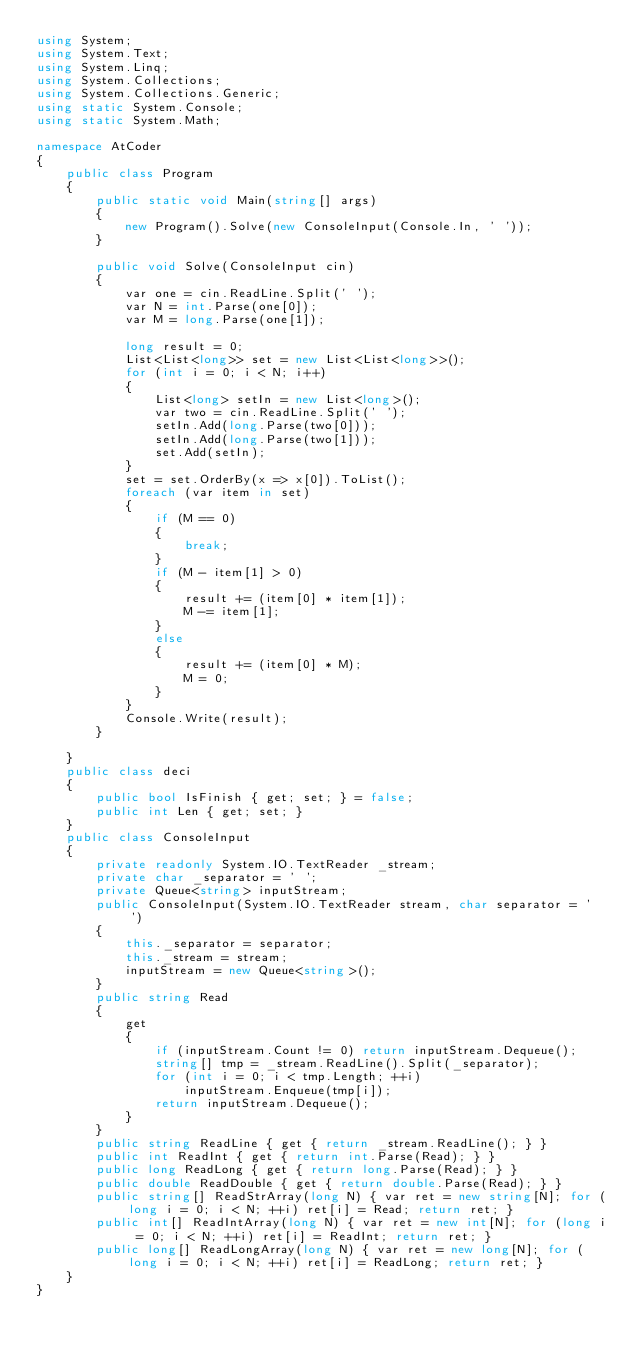<code> <loc_0><loc_0><loc_500><loc_500><_C#_>using System;
using System.Text;
using System.Linq;
using System.Collections;
using System.Collections.Generic;
using static System.Console;
using static System.Math;

namespace AtCoder
{
    public class Program
    {
        public static void Main(string[] args)
        {
            new Program().Solve(new ConsoleInput(Console.In, ' '));
        }

        public void Solve(ConsoleInput cin)
        {
            var one = cin.ReadLine.Split(' ');
            var N = int.Parse(one[0]);
            var M = long.Parse(one[1]);

            long result = 0;
            List<List<long>> set = new List<List<long>>();
            for (int i = 0; i < N; i++)
            {
                List<long> setIn = new List<long>();
                var two = cin.ReadLine.Split(' ');
                setIn.Add(long.Parse(two[0]));
                setIn.Add(long.Parse(two[1]));
                set.Add(setIn);
            }
            set = set.OrderBy(x => x[0]).ToList();
            foreach (var item in set)
            {
                if (M == 0)
                {
                    break;
                }
                if (M - item[1] > 0)
                {
                    result += (item[0] * item[1]);
                    M -= item[1];
                }
                else
                {
                    result += (item[0] * M);
                    M = 0;
                }
            }
            Console.Write(result);
        }

    }
    public class deci
    {
        public bool IsFinish { get; set; } = false;
        public int Len { get; set; }
    }
    public class ConsoleInput
    {
        private readonly System.IO.TextReader _stream;
        private char _separator = ' ';
        private Queue<string> inputStream;
        public ConsoleInput(System.IO.TextReader stream, char separator = ' ')
        {
            this._separator = separator;
            this._stream = stream;
            inputStream = new Queue<string>();
        }
        public string Read
        {
            get
            {
                if (inputStream.Count != 0) return inputStream.Dequeue();
                string[] tmp = _stream.ReadLine().Split(_separator);
                for (int i = 0; i < tmp.Length; ++i)
                    inputStream.Enqueue(tmp[i]);
                return inputStream.Dequeue();
            }
        }
        public string ReadLine { get { return _stream.ReadLine(); } }
        public int ReadInt { get { return int.Parse(Read); } }
        public long ReadLong { get { return long.Parse(Read); } }
        public double ReadDouble { get { return double.Parse(Read); } }
        public string[] ReadStrArray(long N) { var ret = new string[N]; for (long i = 0; i < N; ++i) ret[i] = Read; return ret; }
        public int[] ReadIntArray(long N) { var ret = new int[N]; for (long i = 0; i < N; ++i) ret[i] = ReadInt; return ret; }
        public long[] ReadLongArray(long N) { var ret = new long[N]; for (long i = 0; i < N; ++i) ret[i] = ReadLong; return ret; }
    }
}</code> 